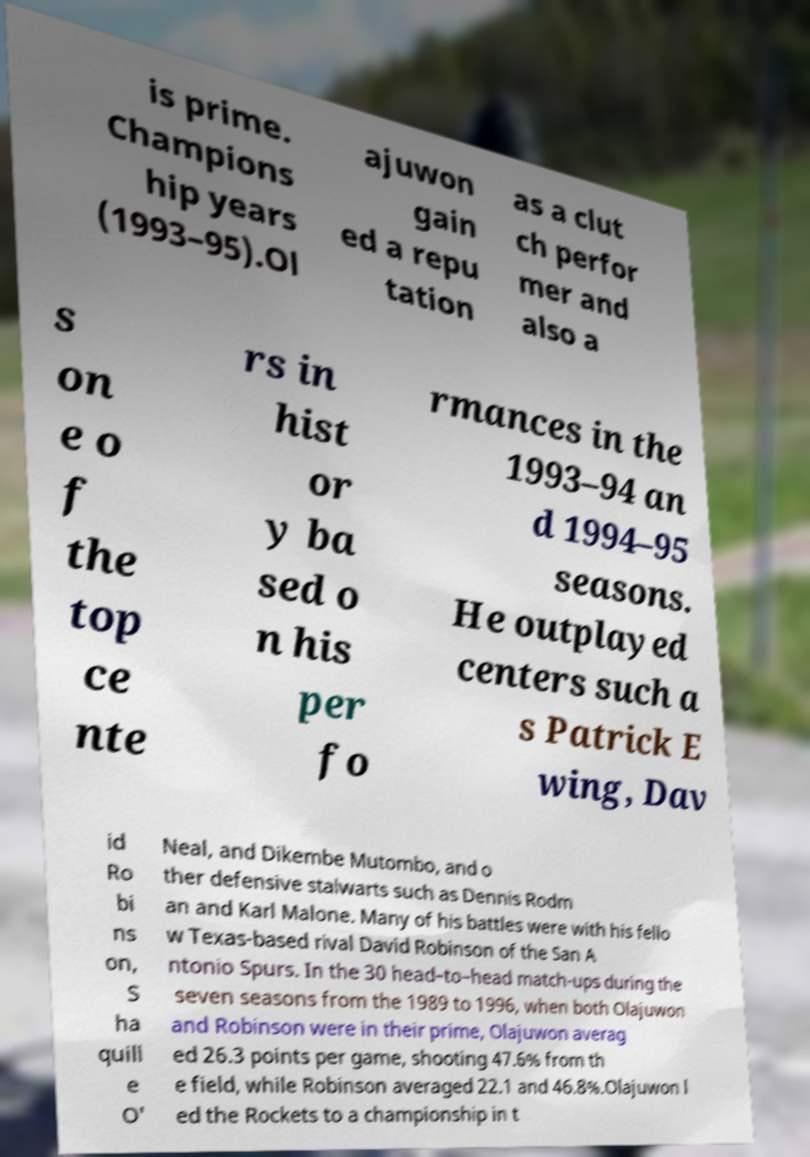There's text embedded in this image that I need extracted. Can you transcribe it verbatim? is prime. Champions hip years (1993–95).Ol ajuwon gain ed a repu tation as a clut ch perfor mer and also a s on e o f the top ce nte rs in hist or y ba sed o n his per fo rmances in the 1993–94 an d 1994–95 seasons. He outplayed centers such a s Patrick E wing, Dav id Ro bi ns on, S ha quill e O' Neal, and Dikembe Mutombo, and o ther defensive stalwarts such as Dennis Rodm an and Karl Malone. Many of his battles were with his fello w Texas-based rival David Robinson of the San A ntonio Spurs. In the 30 head–to–head match-ups during the seven seasons from the 1989 to 1996, when both Olajuwon and Robinson were in their prime, Olajuwon averag ed 26.3 points per game, shooting 47.6% from th e field, while Robinson averaged 22.1 and 46.8%.Olajuwon l ed the Rockets to a championship in t 